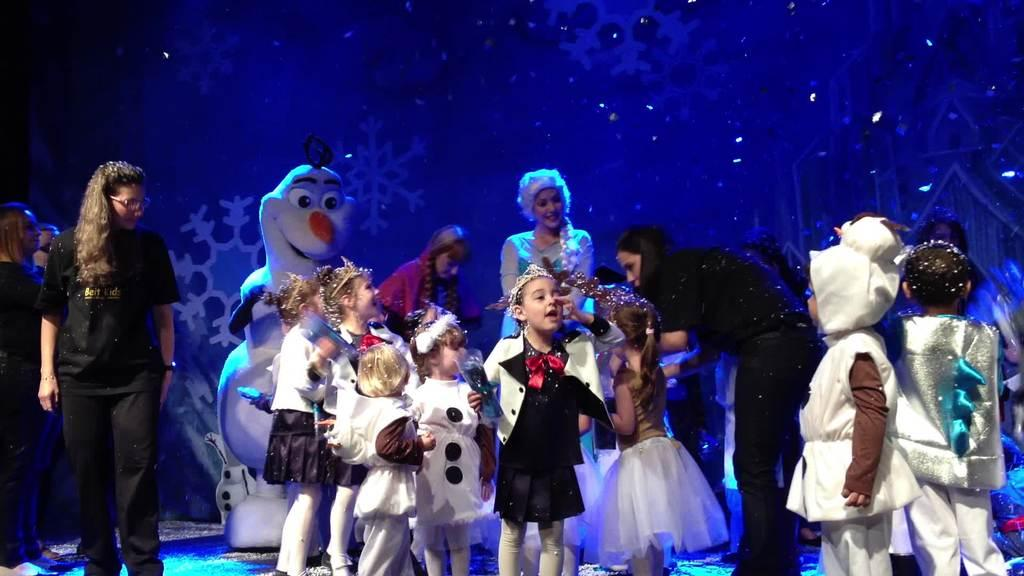What is happening on the stage in the image? There are people on the stage in the image. Can you describe any other characters or objects on the stage? Yes, there is a mascot in the image. What type of glue is being used by the mascot in the image? There is no glue present in the image, and the mascot is not using any glue. 